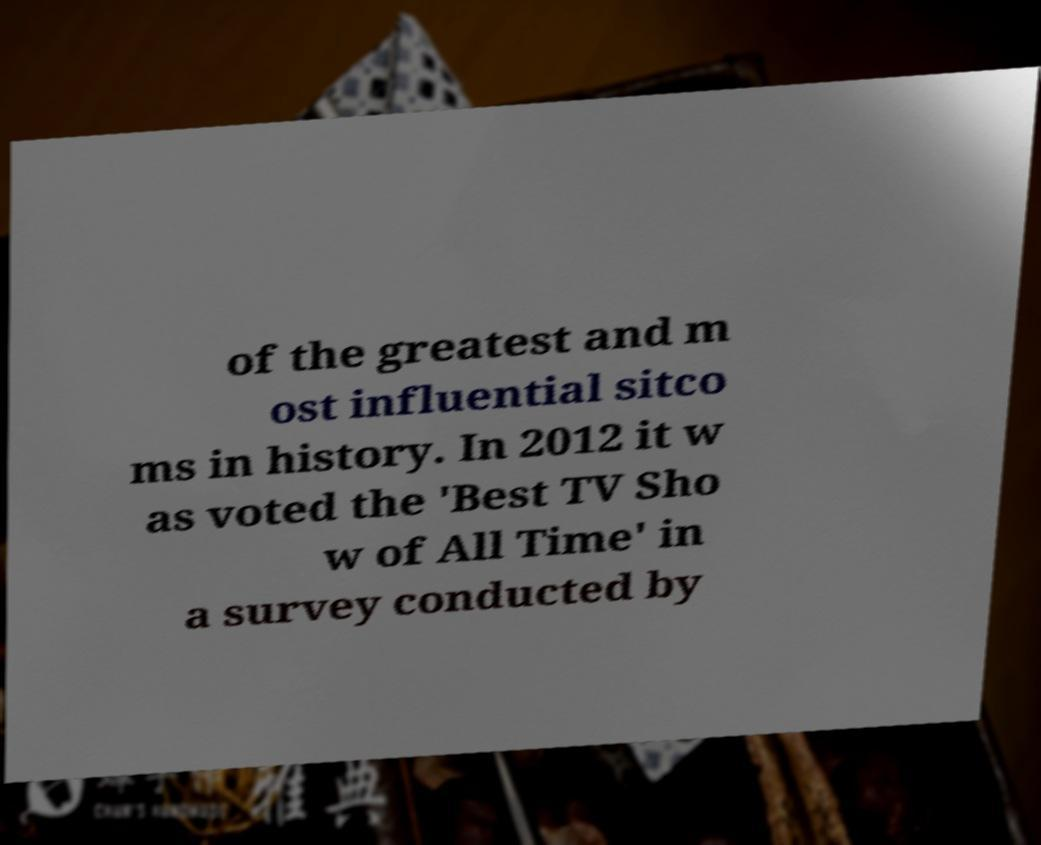There's text embedded in this image that I need extracted. Can you transcribe it verbatim? of the greatest and m ost influential sitco ms in history. In 2012 it w as voted the 'Best TV Sho w of All Time' in a survey conducted by 